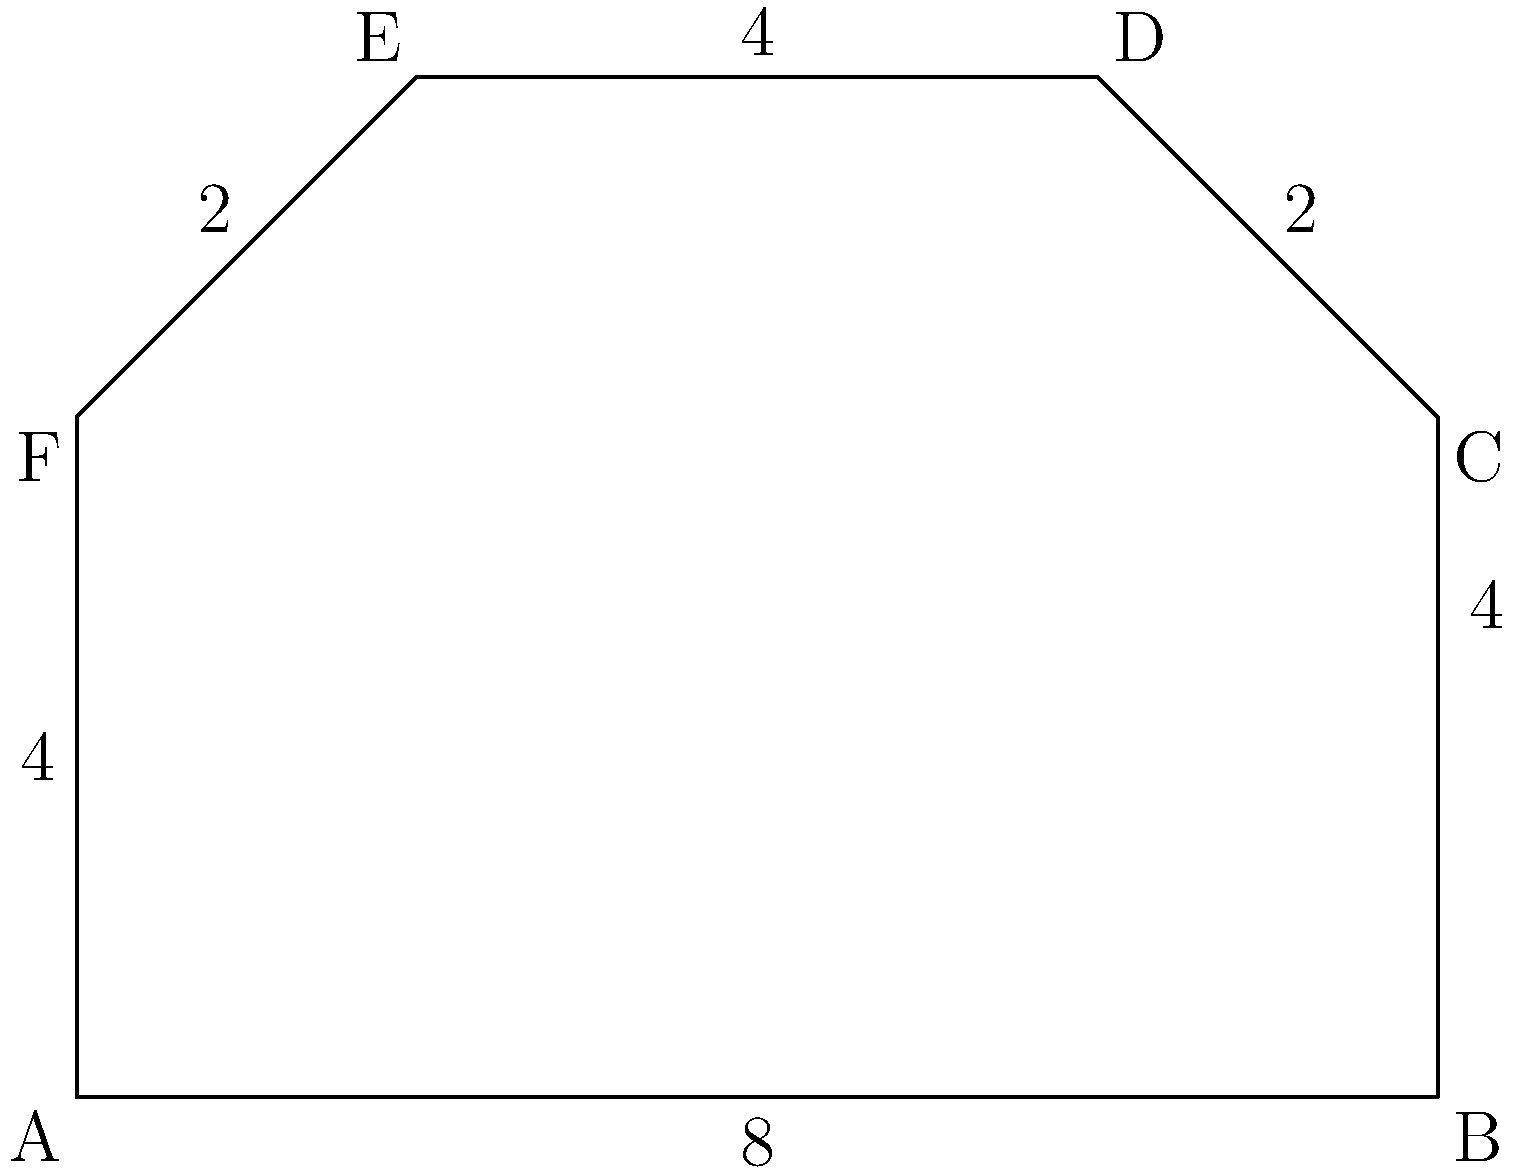As a motorcycle enthusiast involved in organizing a biker rally, you're tasked with calculating the area of a designated parking lot for motorcycles. The lot is represented by the polygon ABCDEF on a coordinate plane, where A(0,0), B(8,0), C(8,4), D(6,6), E(2,6), and F(0,4) are the vertices. What is the area of this parking lot in square units? To find the area of this irregular polygon, we can use the Shoelace formula (also known as the surveyor's formula). The steps are as follows:

1) First, let's arrange the coordinates in order:
   A(0,0), B(8,0), C(8,4), D(6,6), E(2,6), F(0,4)

2) The Shoelace formula is:
   Area = $\frac{1}{2}|((x_1y_2 + x_2y_3 + ... + x_ny_1) - (y_1x_2 + y_2x_3 + ... + y_nx_1))|$

3) Let's calculate each part:
   $(x_1y_2 + x_2y_3 + ... + x_ny_1)$:
   $(0 \cdot 0 + 8 \cdot 4 + 8 \cdot 6 + 6 \cdot 6 + 2 \cdot 4 + 0 \cdot 0) = 32 + 48 + 36 + 8 = 124$

   $(y_1x_2 + y_2x_3 + ... + y_nx_1)$:
   $(0 \cdot 8 + 0 \cdot 8 + 4 \cdot 6 + 6 \cdot 2 + 6 \cdot 0 + 4 \cdot 0) = 24 + 12 = 36$

4) Subtracting:
   $124 - 36 = 88$

5) Taking the absolute value and dividing by 2:
   Area = $\frac{1}{2}|88| = 44$

Therefore, the area of the parking lot is 44 square units.
Answer: 44 square units 